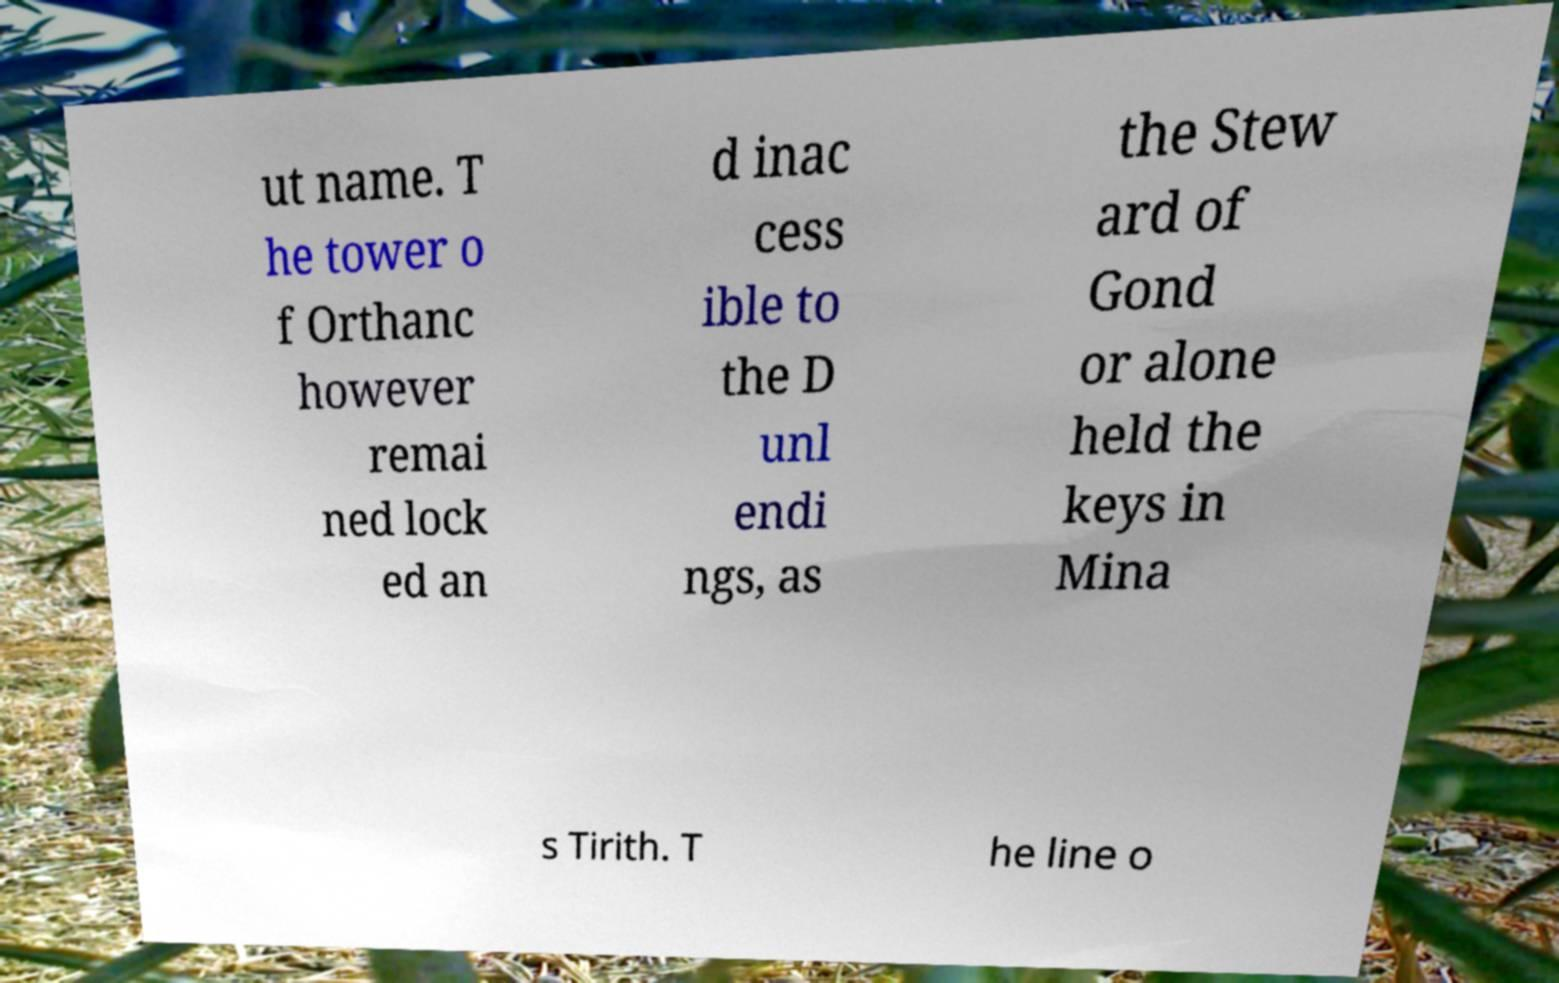Please identify and transcribe the text found in this image. ut name. T he tower o f Orthanc however remai ned lock ed an d inac cess ible to the D unl endi ngs, as the Stew ard of Gond or alone held the keys in Mina s Tirith. T he line o 